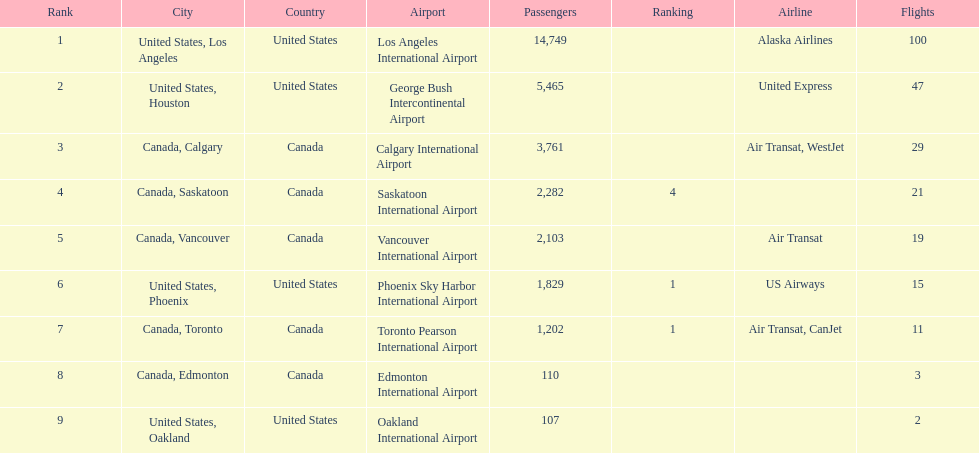How many more passengers flew to los angeles than to saskatoon from manzanillo airport in 2013? 12,467. 